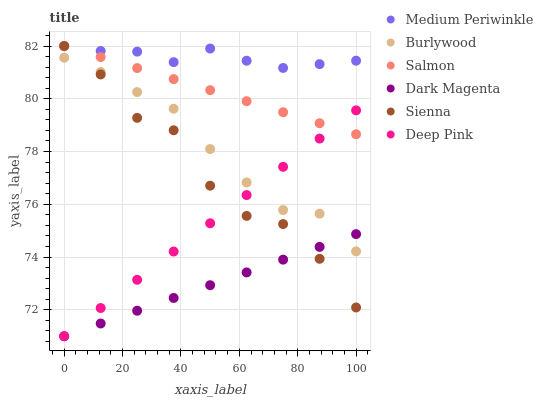Does Dark Magenta have the minimum area under the curve?
Answer yes or no. Yes. Does Medium Periwinkle have the maximum area under the curve?
Answer yes or no. Yes. Does Burlywood have the minimum area under the curve?
Answer yes or no. No. Does Burlywood have the maximum area under the curve?
Answer yes or no. No. Is Deep Pink the smoothest?
Answer yes or no. Yes. Is Sienna the roughest?
Answer yes or no. Yes. Is Dark Magenta the smoothest?
Answer yes or no. No. Is Dark Magenta the roughest?
Answer yes or no. No. Does Deep Pink have the lowest value?
Answer yes or no. Yes. Does Burlywood have the lowest value?
Answer yes or no. No. Does Sienna have the highest value?
Answer yes or no. Yes. Does Burlywood have the highest value?
Answer yes or no. No. Is Dark Magenta less than Medium Periwinkle?
Answer yes or no. Yes. Is Salmon greater than Dark Magenta?
Answer yes or no. Yes. Does Burlywood intersect Sienna?
Answer yes or no. Yes. Is Burlywood less than Sienna?
Answer yes or no. No. Is Burlywood greater than Sienna?
Answer yes or no. No. Does Dark Magenta intersect Medium Periwinkle?
Answer yes or no. No. 